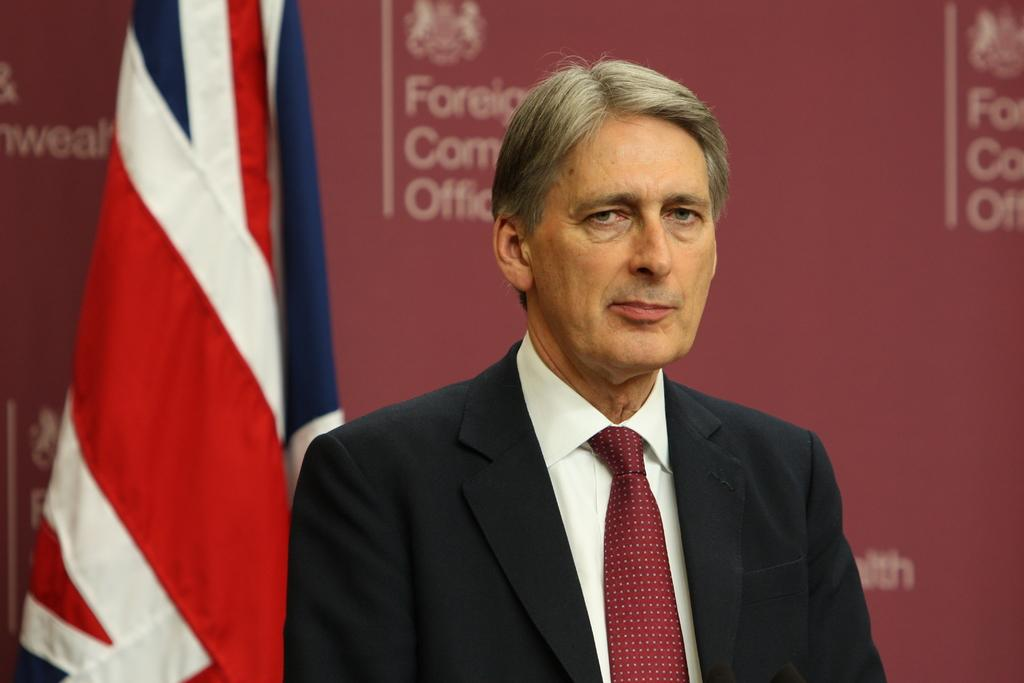Who is present in the image? There is a man in the image. What can be seen in the background of the image? There is a flag in the background of the image. What type of sign is visible in the image? There is an advertisement board with text in the image. What type of reaction can be seen from the pig in the image? There is no pig present in the image, so it is not possible to determine any reaction. 